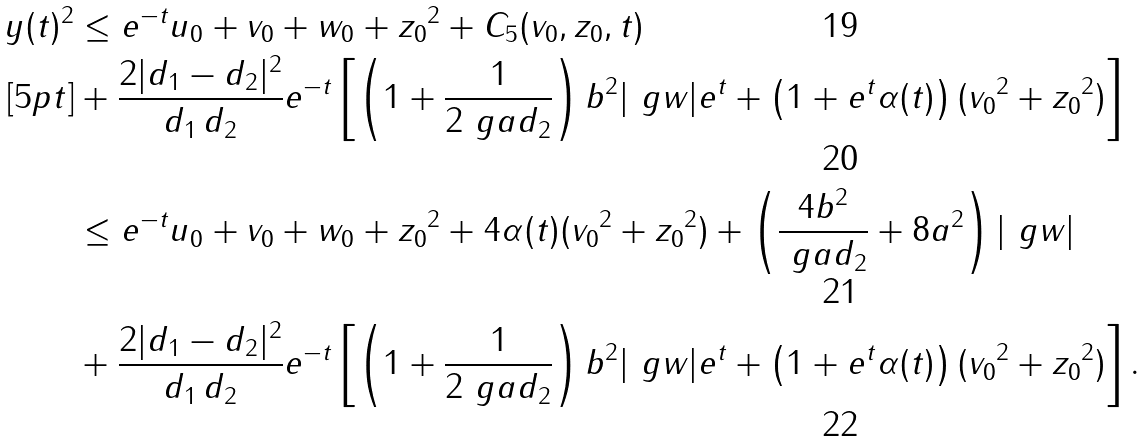<formula> <loc_0><loc_0><loc_500><loc_500>\| y ( t ) \| ^ { 2 } & \leq e ^ { - t } \| u _ { 0 } + v _ { 0 } + w _ { 0 } + z _ { 0 } \| ^ { 2 } + C _ { 5 } ( v _ { 0 } , z _ { 0 } , t ) \\ [ 5 p t ] & + \frac { 2 | d _ { 1 } - d _ { 2 } | ^ { 2 } } { d _ { 1 } \, d _ { 2 } } e ^ { - t } \left [ \left ( 1 + \frac { 1 } { 2 \ g a d _ { 2 } } \right ) b ^ { 2 } | \ g w | e ^ { t } + \left ( 1 + e ^ { t } \alpha ( t ) \right ) ( \| v _ { 0 } \| ^ { 2 } + \| z _ { 0 } \| ^ { 2 } ) \right ] \\ & \leq e ^ { - t } \| u _ { 0 } + v _ { 0 } + w _ { 0 } + z _ { 0 } \| ^ { 2 } + 4 \alpha ( t ) ( \| v _ { 0 } \| ^ { 2 } + \| z _ { 0 } \| ^ { 2 } ) + \left ( \frac { 4 b ^ { 2 } } { \ g a d _ { 2 } } + 8 a ^ { 2 } \right ) | \ g w | \\ & + \frac { 2 | d _ { 1 } - d _ { 2 } | ^ { 2 } } { d _ { 1 } \, d _ { 2 } } e ^ { - t } \left [ \left ( 1 + \frac { 1 } { 2 \ g a d _ { 2 } } \right ) b ^ { 2 } | \ g w | e ^ { t } + \left ( 1 + e ^ { t } \alpha ( t ) \right ) ( \| v _ { 0 } \| ^ { 2 } + \| z _ { 0 } \| ^ { 2 } ) \right ] .</formula> 